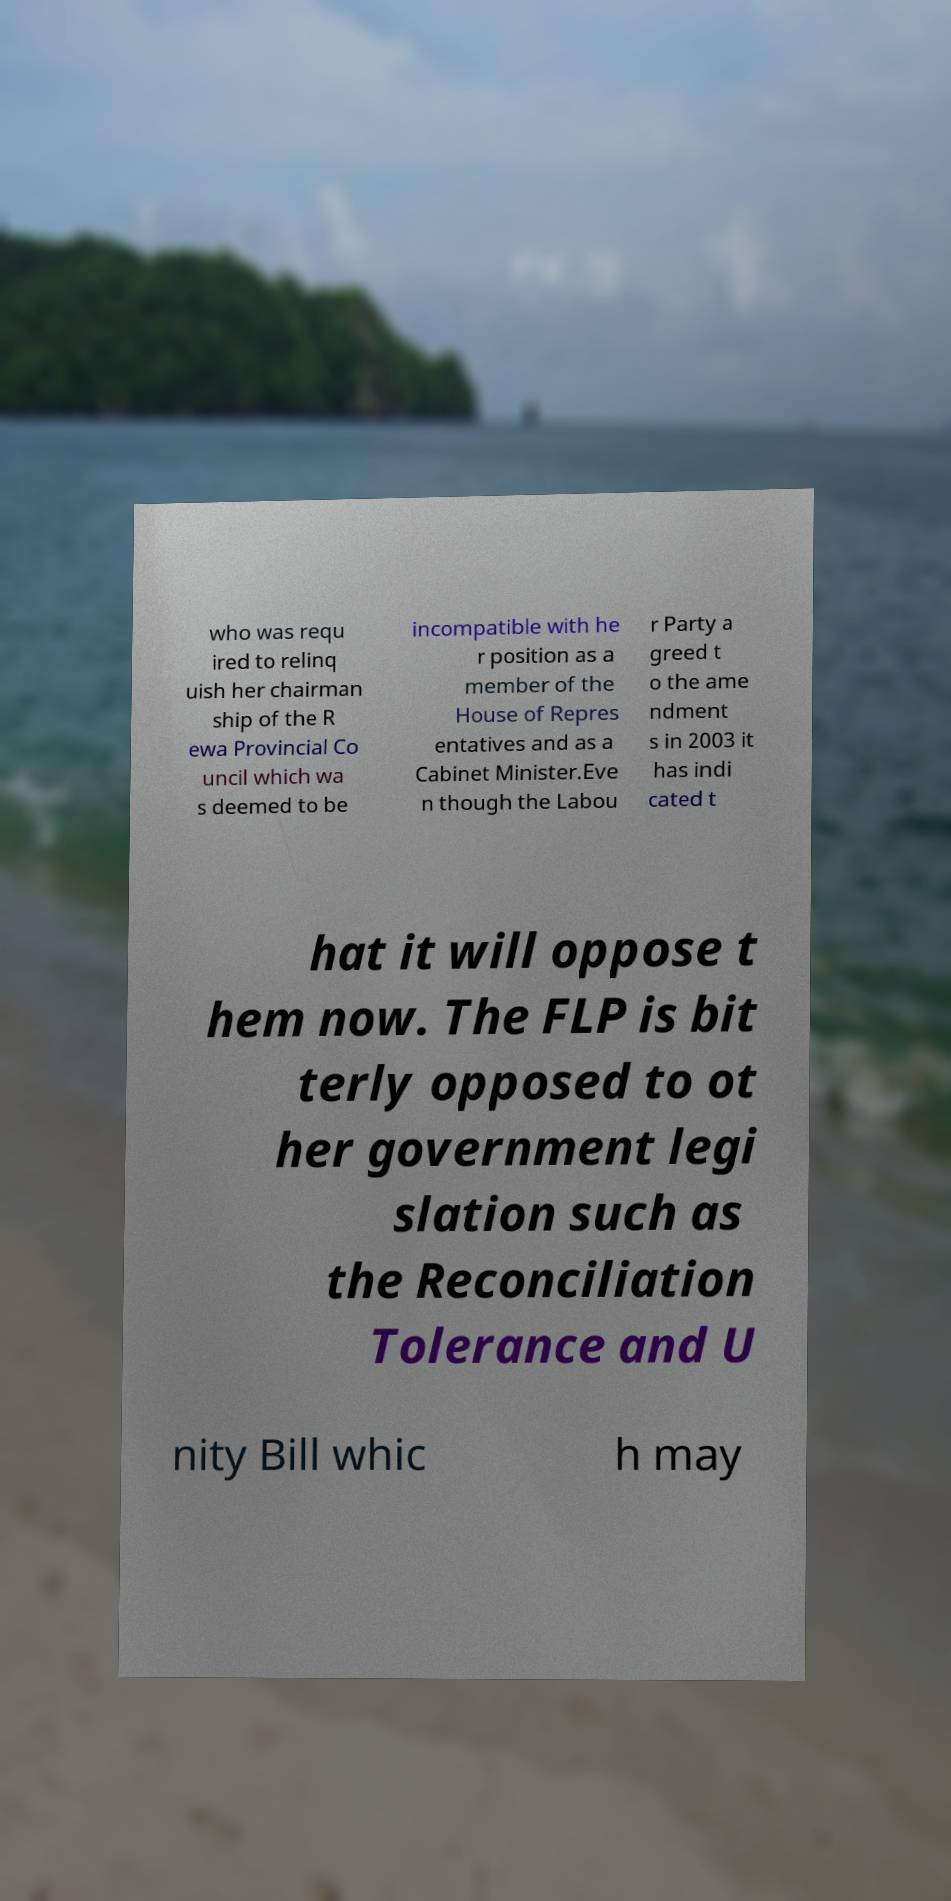Could you assist in decoding the text presented in this image and type it out clearly? who was requ ired to relinq uish her chairman ship of the R ewa Provincial Co uncil which wa s deemed to be incompatible with he r position as a member of the House of Repres entatives and as a Cabinet Minister.Eve n though the Labou r Party a greed t o the ame ndment s in 2003 it has indi cated t hat it will oppose t hem now. The FLP is bit terly opposed to ot her government legi slation such as the Reconciliation Tolerance and U nity Bill whic h may 